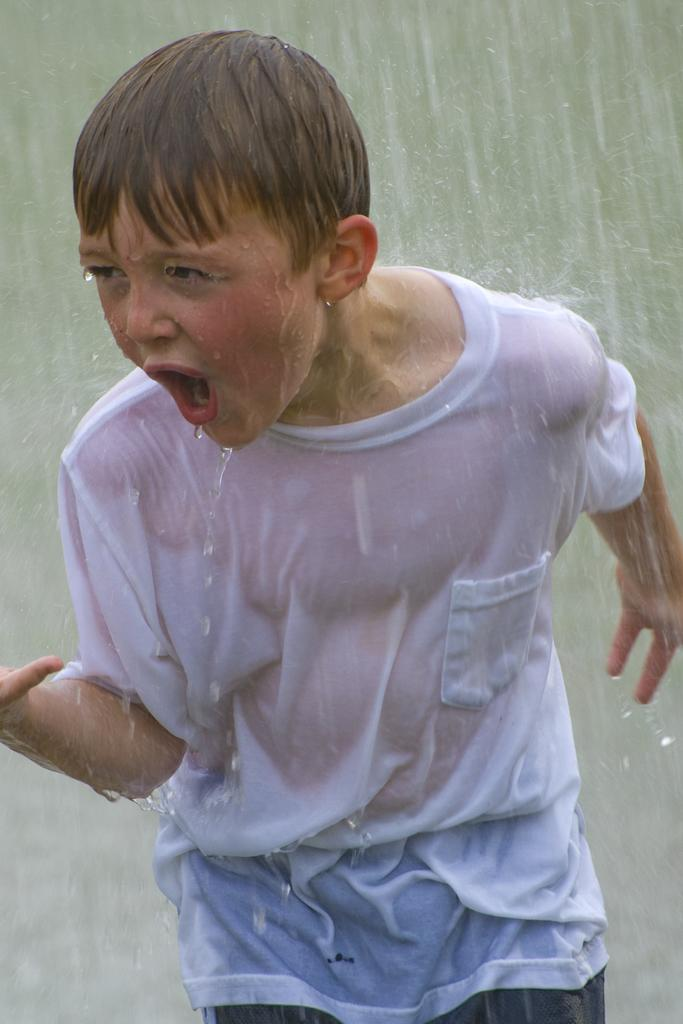Who is the main subject in the image? There is a boy in the image. What is the boy wearing? The boy is wearing a white t-shirt. What is the weather like in the image? It is raining in the image. What type of animal can be seen taking a bath in the tub in the image? There is no tub or animal present in the image; it features a boy wearing a white t-shirt in the rain. 